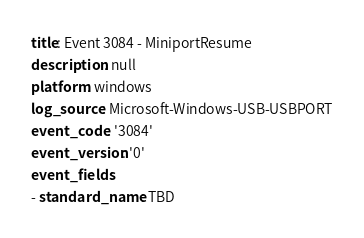<code> <loc_0><loc_0><loc_500><loc_500><_YAML_>title: Event 3084 - MiniportResume
description: null
platform: windows
log_source: Microsoft-Windows-USB-USBPORT
event_code: '3084'
event_version: '0'
event_fields:
- standard_name: TBD</code> 